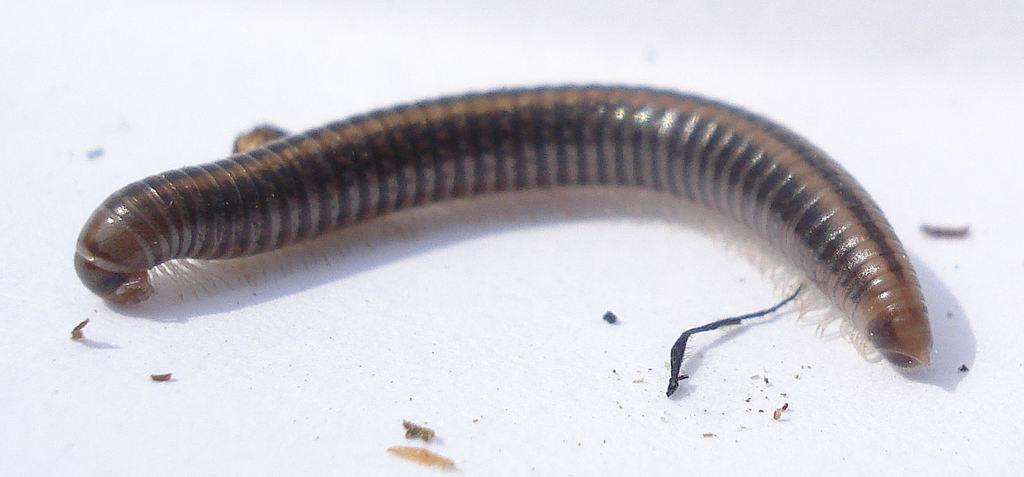Describe this image in one or two sentences. In this image I can see an earthworm and the earthworm is on the white color surface. 